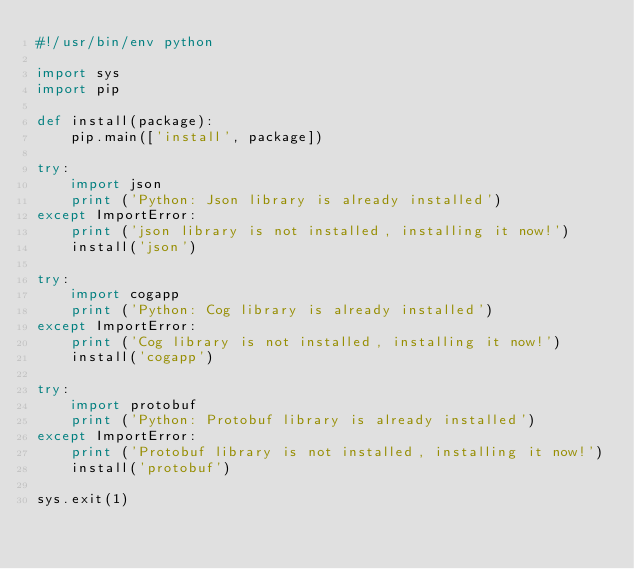<code> <loc_0><loc_0><loc_500><loc_500><_Python_>#!/usr/bin/env python

import sys
import pip

def install(package):
    pip.main(['install', package])

try:
    import json
    print ('Python: Json library is already installed')
except ImportError:
    print ('json library is not installed, installing it now!')
    install('json')

try:
    import cogapp
    print ('Python: Cog library is already installed')
except ImportError:
    print ('Cog library is not installed, installing it now!')
    install('cogapp')

try:
    import protobuf
    print ('Python: Protobuf library is already installed')
except ImportError:
    print ('Protobuf library is not installed, installing it now!')
    install('protobuf')     

sys.exit(1)</code> 